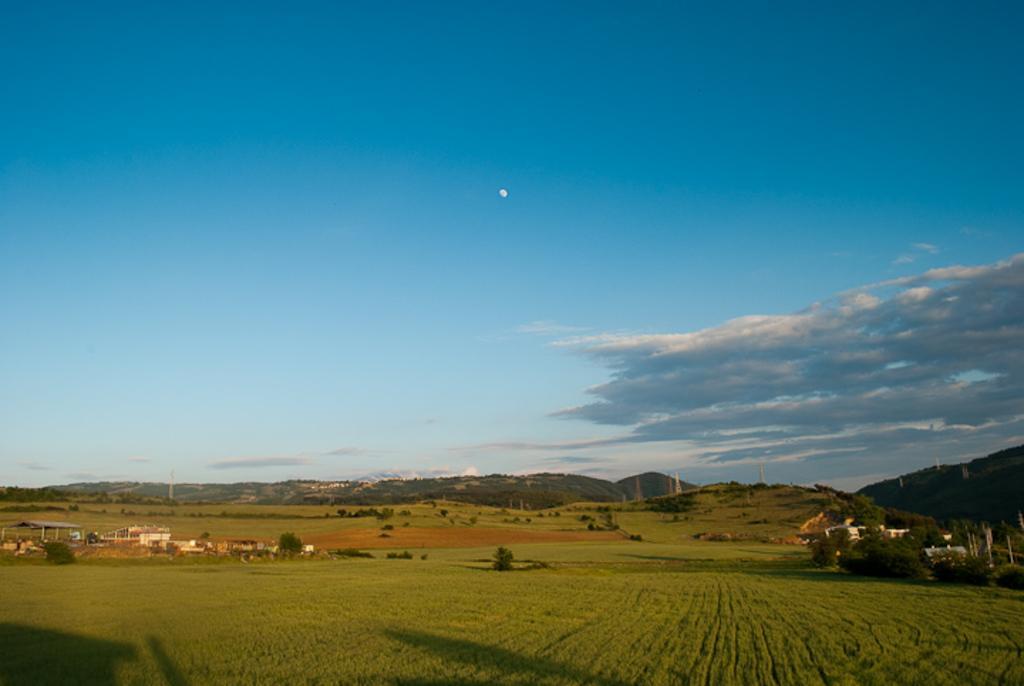Can you describe this image briefly? In this image there is the sky, there are clouds in the sky, there are mountains, there are mountains truncated towards the right of the image, there are towers, there are trees, there are plants, there are buildings, there is the grass. 